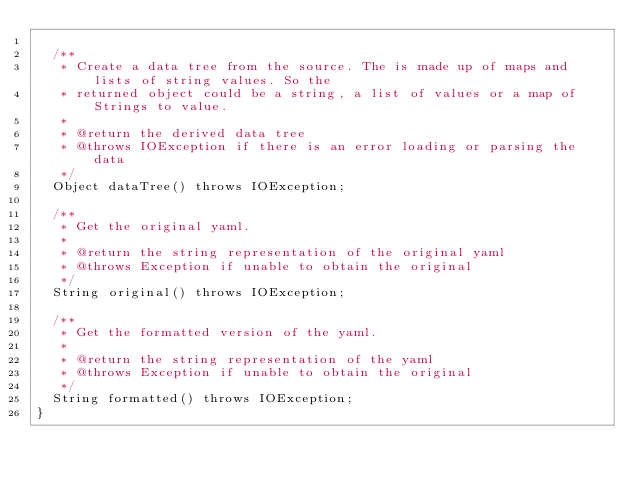Convert code to text. <code><loc_0><loc_0><loc_500><loc_500><_Java_>
  /**
   * Create a data tree from the source. The is made up of maps and lists of string values. So the
   * returned object could be a string, a list of values or a map of Strings to value.
   *
   * @return the derived data tree
   * @throws IOException if there is an error loading or parsing the data
   */
  Object dataTree() throws IOException;

  /**
   * Get the original yaml.
   *
   * @return the string representation of the original yaml
   * @throws Exception if unable to obtain the original
   */
  String original() throws IOException;

  /**
   * Get the formatted version of the yaml.
   *
   * @return the string representation of the yaml
   * @throws Exception if unable to obtain the original
   */
  String formatted() throws IOException;
}
</code> 